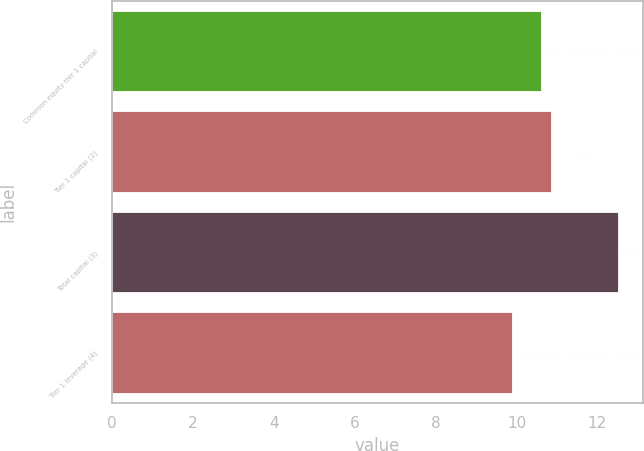Convert chart to OTSL. <chart><loc_0><loc_0><loc_500><loc_500><bar_chart><fcel>Common equity tier 1 capital<fcel>Tier 1 capital (2)<fcel>Total capital (3)<fcel>Tier 1 leverage (4)<nl><fcel>10.6<fcel>10.86<fcel>12.5<fcel>9.9<nl></chart> 